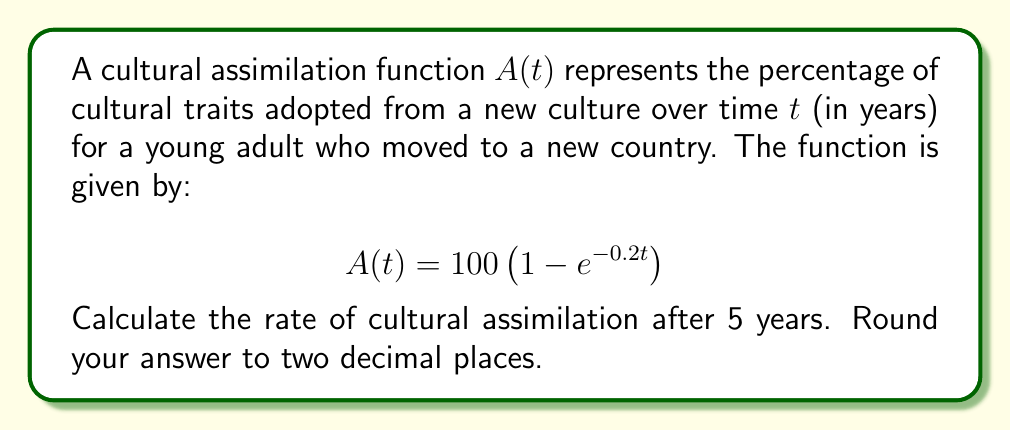Can you answer this question? To find the rate of cultural assimilation, we need to calculate the derivative of $A(t)$ and evaluate it at $t=5$. Let's follow these steps:

1. Calculate the derivative of $A(t)$:
   $$\frac{d}{dt}A(t) = \frac{d}{dt}\left[100 \left(1 - e^{-0.2t}\right)\right]$$
   $$A'(t) = 100 \cdot \frac{d}{dt}\left[1 - e^{-0.2t}\right]$$
   $$A'(t) = 100 \cdot \left(0 - (-0.2)e^{-0.2t}\right)$$
   $$A'(t) = 20e^{-0.2t}$$

2. Evaluate $A'(t)$ at $t=5$:
   $$A'(5) = 20e^{-0.2(5)}$$
   $$A'(5) = 20e^{-1}$$

3. Calculate the value:
   $$A'(5) = 20 \cdot 0.3678794411714423$$
   $$A'(5) \approx 7.3576$$

4. Round to two decimal places:
   $$A'(5) \approx 7.36$$

The rate of cultural assimilation after 5 years is approximately 7.36% per year.
Answer: 7.36% per year 